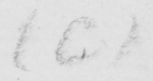What text is written in this handwritten line? ( C ) 